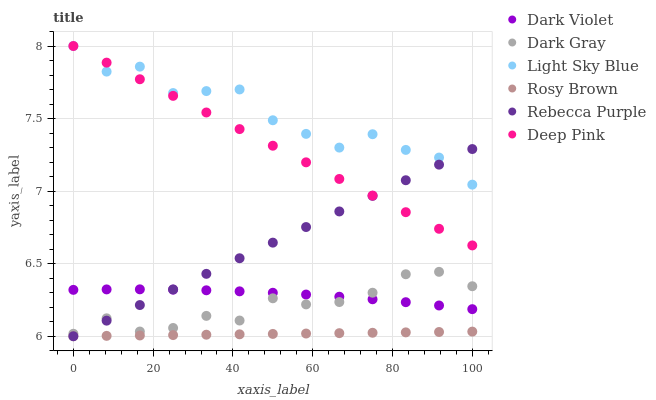Does Rosy Brown have the minimum area under the curve?
Answer yes or no. Yes. Does Light Sky Blue have the maximum area under the curve?
Answer yes or no. Yes. Does Dark Violet have the minimum area under the curve?
Answer yes or no. No. Does Dark Violet have the maximum area under the curve?
Answer yes or no. No. Is Rebecca Purple the smoothest?
Answer yes or no. Yes. Is Light Sky Blue the roughest?
Answer yes or no. Yes. Is Rosy Brown the smoothest?
Answer yes or no. No. Is Rosy Brown the roughest?
Answer yes or no. No. Does Rosy Brown have the lowest value?
Answer yes or no. Yes. Does Dark Violet have the lowest value?
Answer yes or no. No. Does Light Sky Blue have the highest value?
Answer yes or no. Yes. Does Dark Violet have the highest value?
Answer yes or no. No. Is Rosy Brown less than Light Sky Blue?
Answer yes or no. Yes. Is Light Sky Blue greater than Dark Gray?
Answer yes or no. Yes. Does Dark Violet intersect Dark Gray?
Answer yes or no. Yes. Is Dark Violet less than Dark Gray?
Answer yes or no. No. Is Dark Violet greater than Dark Gray?
Answer yes or no. No. Does Rosy Brown intersect Light Sky Blue?
Answer yes or no. No. 